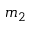<formula> <loc_0><loc_0><loc_500><loc_500>m _ { 2 }</formula> 